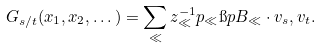<formula> <loc_0><loc_0><loc_500><loc_500>G _ { s / t } ( x _ { 1 } , x _ { 2 } , \dots ) = \sum _ { \ll } z _ { \ll } ^ { - 1 } p _ { \ll } \i p { B _ { \ll } \cdot v _ { s } , v _ { t } } .</formula> 